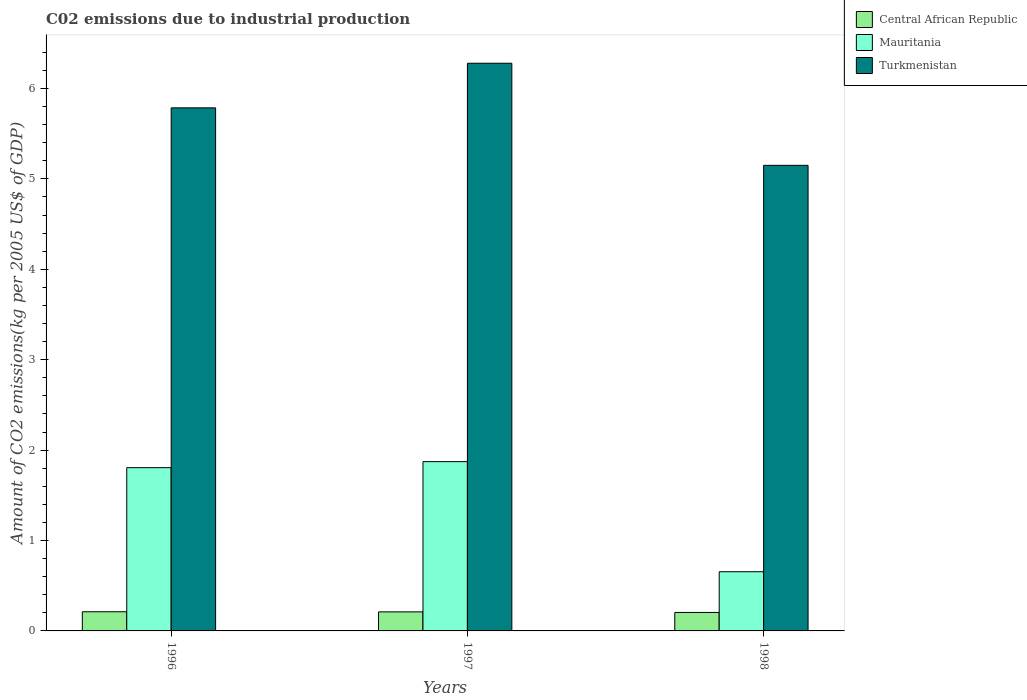Are the number of bars per tick equal to the number of legend labels?
Ensure brevity in your answer.  Yes. Are the number of bars on each tick of the X-axis equal?
Provide a short and direct response. Yes. What is the amount of CO2 emitted due to industrial production in Central African Republic in 1996?
Offer a very short reply. 0.21. Across all years, what is the maximum amount of CO2 emitted due to industrial production in Turkmenistan?
Ensure brevity in your answer.  6.28. Across all years, what is the minimum amount of CO2 emitted due to industrial production in Central African Republic?
Keep it short and to the point. 0.2. In which year was the amount of CO2 emitted due to industrial production in Mauritania maximum?
Your response must be concise. 1997. What is the total amount of CO2 emitted due to industrial production in Mauritania in the graph?
Your answer should be compact. 4.33. What is the difference between the amount of CO2 emitted due to industrial production in Central African Republic in 1996 and that in 1997?
Your response must be concise. 0. What is the difference between the amount of CO2 emitted due to industrial production in Mauritania in 1997 and the amount of CO2 emitted due to industrial production in Central African Republic in 1996?
Provide a succinct answer. 1.66. What is the average amount of CO2 emitted due to industrial production in Turkmenistan per year?
Offer a very short reply. 5.74. In the year 1997, what is the difference between the amount of CO2 emitted due to industrial production in Turkmenistan and amount of CO2 emitted due to industrial production in Central African Republic?
Offer a terse response. 6.07. What is the ratio of the amount of CO2 emitted due to industrial production in Turkmenistan in 1997 to that in 1998?
Provide a succinct answer. 1.22. Is the difference between the amount of CO2 emitted due to industrial production in Turkmenistan in 1996 and 1998 greater than the difference between the amount of CO2 emitted due to industrial production in Central African Republic in 1996 and 1998?
Ensure brevity in your answer.  Yes. What is the difference between the highest and the second highest amount of CO2 emitted due to industrial production in Central African Republic?
Your answer should be compact. 0. What is the difference between the highest and the lowest amount of CO2 emitted due to industrial production in Mauritania?
Keep it short and to the point. 1.22. Is the sum of the amount of CO2 emitted due to industrial production in Mauritania in 1997 and 1998 greater than the maximum amount of CO2 emitted due to industrial production in Turkmenistan across all years?
Ensure brevity in your answer.  No. What does the 1st bar from the left in 1997 represents?
Your response must be concise. Central African Republic. What does the 3rd bar from the right in 1996 represents?
Give a very brief answer. Central African Republic. Is it the case that in every year, the sum of the amount of CO2 emitted due to industrial production in Mauritania and amount of CO2 emitted due to industrial production in Central African Republic is greater than the amount of CO2 emitted due to industrial production in Turkmenistan?
Ensure brevity in your answer.  No. Are all the bars in the graph horizontal?
Your response must be concise. No. How many years are there in the graph?
Offer a terse response. 3. Are the values on the major ticks of Y-axis written in scientific E-notation?
Offer a terse response. No. Does the graph contain any zero values?
Give a very brief answer. No. How are the legend labels stacked?
Provide a short and direct response. Vertical. What is the title of the graph?
Provide a short and direct response. C02 emissions due to industrial production. What is the label or title of the X-axis?
Make the answer very short. Years. What is the label or title of the Y-axis?
Your answer should be very brief. Amount of CO2 emissions(kg per 2005 US$ of GDP). What is the Amount of CO2 emissions(kg per 2005 US$ of GDP) in Central African Republic in 1996?
Give a very brief answer. 0.21. What is the Amount of CO2 emissions(kg per 2005 US$ of GDP) of Mauritania in 1996?
Your answer should be very brief. 1.81. What is the Amount of CO2 emissions(kg per 2005 US$ of GDP) of Turkmenistan in 1996?
Ensure brevity in your answer.  5.79. What is the Amount of CO2 emissions(kg per 2005 US$ of GDP) in Central African Republic in 1997?
Your response must be concise. 0.21. What is the Amount of CO2 emissions(kg per 2005 US$ of GDP) in Mauritania in 1997?
Ensure brevity in your answer.  1.87. What is the Amount of CO2 emissions(kg per 2005 US$ of GDP) of Turkmenistan in 1997?
Ensure brevity in your answer.  6.28. What is the Amount of CO2 emissions(kg per 2005 US$ of GDP) of Central African Republic in 1998?
Provide a succinct answer. 0.2. What is the Amount of CO2 emissions(kg per 2005 US$ of GDP) in Mauritania in 1998?
Keep it short and to the point. 0.65. What is the Amount of CO2 emissions(kg per 2005 US$ of GDP) of Turkmenistan in 1998?
Provide a succinct answer. 5.15. Across all years, what is the maximum Amount of CO2 emissions(kg per 2005 US$ of GDP) in Central African Republic?
Offer a terse response. 0.21. Across all years, what is the maximum Amount of CO2 emissions(kg per 2005 US$ of GDP) in Mauritania?
Your response must be concise. 1.87. Across all years, what is the maximum Amount of CO2 emissions(kg per 2005 US$ of GDP) of Turkmenistan?
Ensure brevity in your answer.  6.28. Across all years, what is the minimum Amount of CO2 emissions(kg per 2005 US$ of GDP) in Central African Republic?
Your response must be concise. 0.2. Across all years, what is the minimum Amount of CO2 emissions(kg per 2005 US$ of GDP) in Mauritania?
Provide a short and direct response. 0.65. Across all years, what is the minimum Amount of CO2 emissions(kg per 2005 US$ of GDP) of Turkmenistan?
Ensure brevity in your answer.  5.15. What is the total Amount of CO2 emissions(kg per 2005 US$ of GDP) of Central African Republic in the graph?
Make the answer very short. 0.63. What is the total Amount of CO2 emissions(kg per 2005 US$ of GDP) of Mauritania in the graph?
Ensure brevity in your answer.  4.33. What is the total Amount of CO2 emissions(kg per 2005 US$ of GDP) in Turkmenistan in the graph?
Give a very brief answer. 17.21. What is the difference between the Amount of CO2 emissions(kg per 2005 US$ of GDP) of Central African Republic in 1996 and that in 1997?
Make the answer very short. 0. What is the difference between the Amount of CO2 emissions(kg per 2005 US$ of GDP) in Mauritania in 1996 and that in 1997?
Your answer should be compact. -0.07. What is the difference between the Amount of CO2 emissions(kg per 2005 US$ of GDP) in Turkmenistan in 1996 and that in 1997?
Your response must be concise. -0.49. What is the difference between the Amount of CO2 emissions(kg per 2005 US$ of GDP) of Central African Republic in 1996 and that in 1998?
Your response must be concise. 0.01. What is the difference between the Amount of CO2 emissions(kg per 2005 US$ of GDP) of Mauritania in 1996 and that in 1998?
Your response must be concise. 1.15. What is the difference between the Amount of CO2 emissions(kg per 2005 US$ of GDP) in Turkmenistan in 1996 and that in 1998?
Your answer should be compact. 0.64. What is the difference between the Amount of CO2 emissions(kg per 2005 US$ of GDP) in Central African Republic in 1997 and that in 1998?
Your answer should be compact. 0.01. What is the difference between the Amount of CO2 emissions(kg per 2005 US$ of GDP) in Mauritania in 1997 and that in 1998?
Offer a terse response. 1.22. What is the difference between the Amount of CO2 emissions(kg per 2005 US$ of GDP) of Turkmenistan in 1997 and that in 1998?
Keep it short and to the point. 1.13. What is the difference between the Amount of CO2 emissions(kg per 2005 US$ of GDP) in Central African Republic in 1996 and the Amount of CO2 emissions(kg per 2005 US$ of GDP) in Mauritania in 1997?
Offer a very short reply. -1.66. What is the difference between the Amount of CO2 emissions(kg per 2005 US$ of GDP) of Central African Republic in 1996 and the Amount of CO2 emissions(kg per 2005 US$ of GDP) of Turkmenistan in 1997?
Your answer should be compact. -6.07. What is the difference between the Amount of CO2 emissions(kg per 2005 US$ of GDP) in Mauritania in 1996 and the Amount of CO2 emissions(kg per 2005 US$ of GDP) in Turkmenistan in 1997?
Give a very brief answer. -4.47. What is the difference between the Amount of CO2 emissions(kg per 2005 US$ of GDP) of Central African Republic in 1996 and the Amount of CO2 emissions(kg per 2005 US$ of GDP) of Mauritania in 1998?
Provide a succinct answer. -0.44. What is the difference between the Amount of CO2 emissions(kg per 2005 US$ of GDP) in Central African Republic in 1996 and the Amount of CO2 emissions(kg per 2005 US$ of GDP) in Turkmenistan in 1998?
Keep it short and to the point. -4.94. What is the difference between the Amount of CO2 emissions(kg per 2005 US$ of GDP) in Mauritania in 1996 and the Amount of CO2 emissions(kg per 2005 US$ of GDP) in Turkmenistan in 1998?
Give a very brief answer. -3.34. What is the difference between the Amount of CO2 emissions(kg per 2005 US$ of GDP) of Central African Republic in 1997 and the Amount of CO2 emissions(kg per 2005 US$ of GDP) of Mauritania in 1998?
Keep it short and to the point. -0.44. What is the difference between the Amount of CO2 emissions(kg per 2005 US$ of GDP) of Central African Republic in 1997 and the Amount of CO2 emissions(kg per 2005 US$ of GDP) of Turkmenistan in 1998?
Your answer should be very brief. -4.94. What is the difference between the Amount of CO2 emissions(kg per 2005 US$ of GDP) in Mauritania in 1997 and the Amount of CO2 emissions(kg per 2005 US$ of GDP) in Turkmenistan in 1998?
Your answer should be compact. -3.28. What is the average Amount of CO2 emissions(kg per 2005 US$ of GDP) in Central African Republic per year?
Provide a succinct answer. 0.21. What is the average Amount of CO2 emissions(kg per 2005 US$ of GDP) in Mauritania per year?
Your answer should be very brief. 1.44. What is the average Amount of CO2 emissions(kg per 2005 US$ of GDP) of Turkmenistan per year?
Make the answer very short. 5.74. In the year 1996, what is the difference between the Amount of CO2 emissions(kg per 2005 US$ of GDP) of Central African Republic and Amount of CO2 emissions(kg per 2005 US$ of GDP) of Mauritania?
Offer a terse response. -1.59. In the year 1996, what is the difference between the Amount of CO2 emissions(kg per 2005 US$ of GDP) in Central African Republic and Amount of CO2 emissions(kg per 2005 US$ of GDP) in Turkmenistan?
Ensure brevity in your answer.  -5.57. In the year 1996, what is the difference between the Amount of CO2 emissions(kg per 2005 US$ of GDP) in Mauritania and Amount of CO2 emissions(kg per 2005 US$ of GDP) in Turkmenistan?
Your response must be concise. -3.98. In the year 1997, what is the difference between the Amount of CO2 emissions(kg per 2005 US$ of GDP) in Central African Republic and Amount of CO2 emissions(kg per 2005 US$ of GDP) in Mauritania?
Your answer should be very brief. -1.66. In the year 1997, what is the difference between the Amount of CO2 emissions(kg per 2005 US$ of GDP) of Central African Republic and Amount of CO2 emissions(kg per 2005 US$ of GDP) of Turkmenistan?
Keep it short and to the point. -6.07. In the year 1997, what is the difference between the Amount of CO2 emissions(kg per 2005 US$ of GDP) in Mauritania and Amount of CO2 emissions(kg per 2005 US$ of GDP) in Turkmenistan?
Ensure brevity in your answer.  -4.41. In the year 1998, what is the difference between the Amount of CO2 emissions(kg per 2005 US$ of GDP) of Central African Republic and Amount of CO2 emissions(kg per 2005 US$ of GDP) of Mauritania?
Your answer should be very brief. -0.45. In the year 1998, what is the difference between the Amount of CO2 emissions(kg per 2005 US$ of GDP) of Central African Republic and Amount of CO2 emissions(kg per 2005 US$ of GDP) of Turkmenistan?
Provide a succinct answer. -4.95. In the year 1998, what is the difference between the Amount of CO2 emissions(kg per 2005 US$ of GDP) in Mauritania and Amount of CO2 emissions(kg per 2005 US$ of GDP) in Turkmenistan?
Your response must be concise. -4.5. What is the ratio of the Amount of CO2 emissions(kg per 2005 US$ of GDP) of Central African Republic in 1996 to that in 1997?
Offer a very short reply. 1.01. What is the ratio of the Amount of CO2 emissions(kg per 2005 US$ of GDP) of Turkmenistan in 1996 to that in 1997?
Ensure brevity in your answer.  0.92. What is the ratio of the Amount of CO2 emissions(kg per 2005 US$ of GDP) of Central African Republic in 1996 to that in 1998?
Offer a terse response. 1.04. What is the ratio of the Amount of CO2 emissions(kg per 2005 US$ of GDP) in Mauritania in 1996 to that in 1998?
Provide a succinct answer. 2.76. What is the ratio of the Amount of CO2 emissions(kg per 2005 US$ of GDP) in Turkmenistan in 1996 to that in 1998?
Give a very brief answer. 1.12. What is the ratio of the Amount of CO2 emissions(kg per 2005 US$ of GDP) in Central African Republic in 1997 to that in 1998?
Give a very brief answer. 1.03. What is the ratio of the Amount of CO2 emissions(kg per 2005 US$ of GDP) of Mauritania in 1997 to that in 1998?
Offer a terse response. 2.86. What is the ratio of the Amount of CO2 emissions(kg per 2005 US$ of GDP) in Turkmenistan in 1997 to that in 1998?
Offer a terse response. 1.22. What is the difference between the highest and the second highest Amount of CO2 emissions(kg per 2005 US$ of GDP) of Central African Republic?
Provide a short and direct response. 0. What is the difference between the highest and the second highest Amount of CO2 emissions(kg per 2005 US$ of GDP) of Mauritania?
Give a very brief answer. 0.07. What is the difference between the highest and the second highest Amount of CO2 emissions(kg per 2005 US$ of GDP) in Turkmenistan?
Offer a terse response. 0.49. What is the difference between the highest and the lowest Amount of CO2 emissions(kg per 2005 US$ of GDP) of Central African Republic?
Keep it short and to the point. 0.01. What is the difference between the highest and the lowest Amount of CO2 emissions(kg per 2005 US$ of GDP) in Mauritania?
Offer a terse response. 1.22. What is the difference between the highest and the lowest Amount of CO2 emissions(kg per 2005 US$ of GDP) of Turkmenistan?
Your response must be concise. 1.13. 